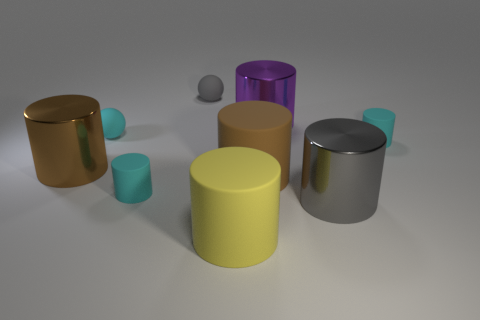Subtract all gray cylinders. How many cylinders are left? 6 Subtract all tiny matte cylinders. How many cylinders are left? 5 Subtract all cyan cylinders. Subtract all brown blocks. How many cylinders are left? 5 Add 1 brown shiny objects. How many objects exist? 10 Subtract all balls. How many objects are left? 7 Subtract 0 blue cylinders. How many objects are left? 9 Subtract all gray rubber objects. Subtract all cyan rubber balls. How many objects are left? 7 Add 4 cyan cylinders. How many cyan cylinders are left? 6 Add 2 purple cylinders. How many purple cylinders exist? 3 